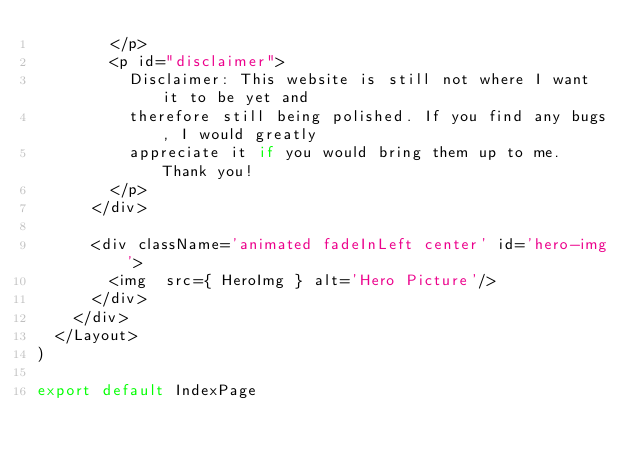<code> <loc_0><loc_0><loc_500><loc_500><_JavaScript_>        </p>
        <p id="disclaimer">
          Disclaimer: This website is still not where I want it to be yet and
          therefore still being polished. If you find any bugs, I would greatly
          appreciate it if you would bring them up to me. Thank you!
        </p>
      </div>

      <div className='animated fadeInLeft center' id='hero-img'>
        <img  src={ HeroImg } alt='Hero Picture'/>
      </div>
    </div>
  </Layout>
)

export default IndexPage
</code> 